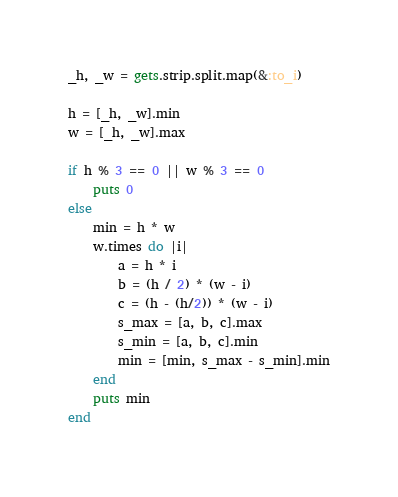<code> <loc_0><loc_0><loc_500><loc_500><_Ruby_>_h, _w = gets.strip.split.map(&:to_i)

h = [_h, _w].min
w = [_h, _w].max

if h % 3 == 0 || w % 3 == 0
    puts 0
else
    min = h * w
    w.times do |i|
        a = h * i
        b = (h / 2) * (w - i)
        c = (h - (h/2)) * (w - i)
        s_max = [a, b, c].max
        s_min = [a, b, c].min
        min = [min, s_max - s_min].min
    end
    puts min
end</code> 